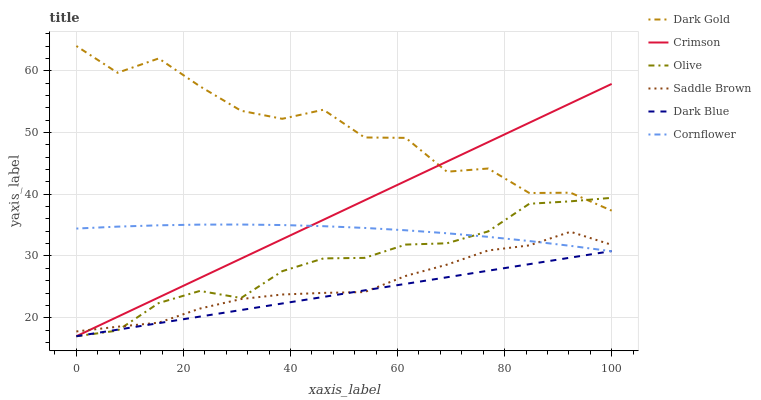Does Dark Gold have the minimum area under the curve?
Answer yes or no. No. Does Dark Blue have the maximum area under the curve?
Answer yes or no. No. Is Dark Gold the smoothest?
Answer yes or no. No. Is Dark Blue the roughest?
Answer yes or no. No. Does Dark Gold have the lowest value?
Answer yes or no. No. Does Dark Blue have the highest value?
Answer yes or no. No. Is Saddle Brown less than Dark Gold?
Answer yes or no. Yes. Is Dark Gold greater than Saddle Brown?
Answer yes or no. Yes. Does Saddle Brown intersect Dark Gold?
Answer yes or no. No. 